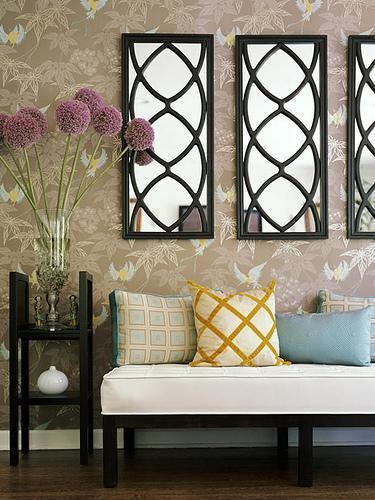How many mirrors are fully visible?
Give a very brief answer. 2. 